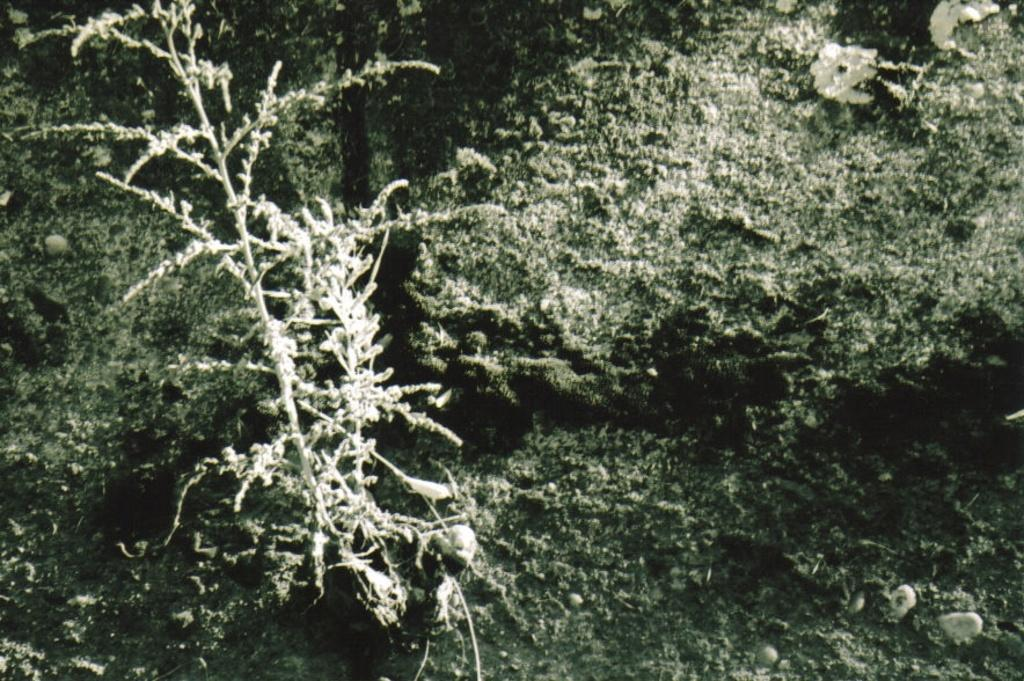What type of organic matter can be seen around the area of the image? There is algae around the area of the image. What can be found on the left side of the image? There is a plant on the left side of the image. What type of shoes can be seen in the image? There are no shoes present in the image. What shape is the egg in the image? There is no egg present in the image. 